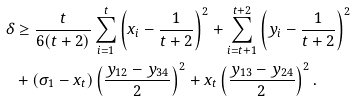Convert formula to latex. <formula><loc_0><loc_0><loc_500><loc_500>\delta & \geq \frac { t } { 6 ( t + 2 ) } \sum _ { i = 1 } ^ { t } \left ( x _ { i } - \frac { 1 } { t + 2 } \right ) ^ { 2 } + \sum _ { i = t + 1 } ^ { t + 2 } \left ( y _ { i } - \frac { 1 } { t + 2 } \right ) ^ { 2 } \\ & + ( \sigma _ { 1 } - x _ { t } ) \left ( \frac { y _ { 1 2 } - y _ { 3 4 } } { 2 } \right ) ^ { 2 } + x _ { t } \left ( \frac { y _ { 1 3 } - y _ { 2 4 } } { 2 } \right ) ^ { 2 } .</formula> 